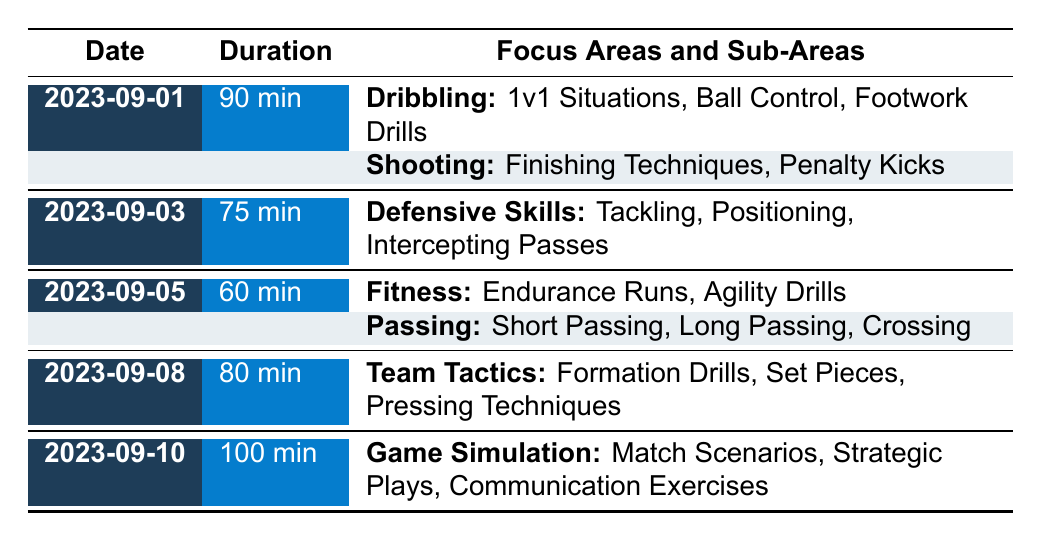What is the duration of the training session on September 5? The table shows that on September 5, the training session lasted for 60 minutes.
Answer: 60 min Which focus area was covered during the training session on September 10? The table indicates that on September 10, the focus area was "Game Simulation".
Answer: Game Simulation How many different focus areas were included on September 1? On September 1, there were two focus areas listed: "Dribbling" and "Shooting".
Answer: 2 What is the total duration of training sessions from September 1 to September 5? Adding the durations: 90 (Sept 1) + 75 (Sept 3) + 60 (Sept 5) = 225 minutes.
Answer: 225 min Did the training on September 8 include a focus area related to fitness? The table lists "Team Tactics" as the only focus area for September 8, which does not include fitness.
Answer: No Which training session had the longest duration and what was it? The table shows that the training on September 10 had the longest duration of 100 minutes.
Answer: 100 min How many sub-areas were covered during the training session on September 5? For September 5, the "Fitness" area has 2 sub-areas and "Passing" has 3, totaling 5 sub-areas.
Answer: 5 Was there a training session that focused solely on defensive skills? Yes, the training session on September 3 focused only on "Defensive Skills".
Answer: Yes What was the average duration of the training sessions listed in the table? The durations are 90, 75, 60, 80, and 100 minutes. The total is 405 minutes, and with 5 sessions, the average is 405/5 = 81 minutes.
Answer: 81 min 